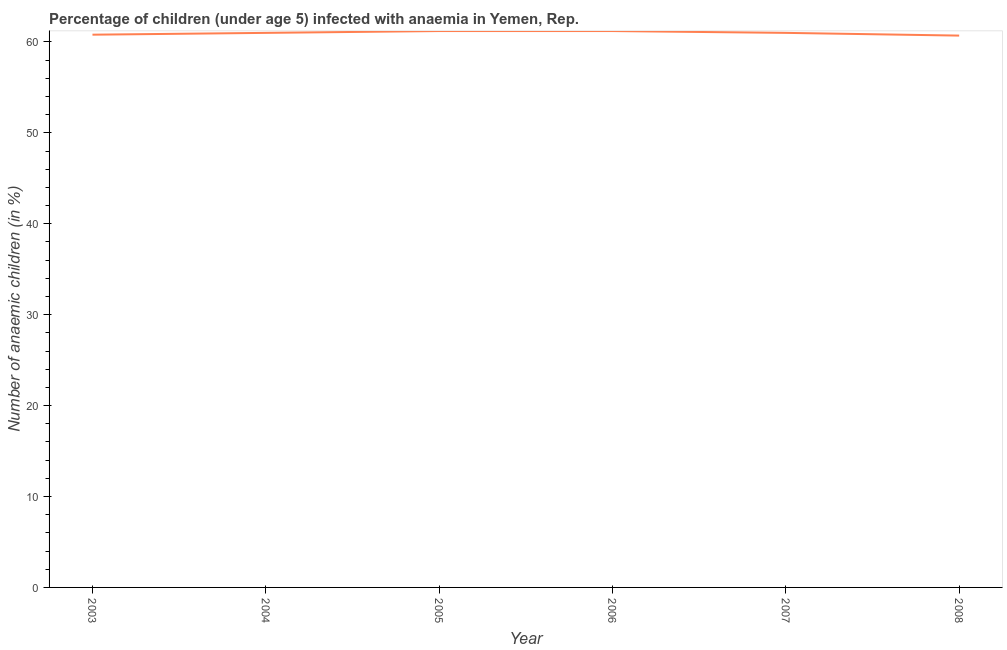Across all years, what is the maximum number of anaemic children?
Your answer should be compact. 61.2. Across all years, what is the minimum number of anaemic children?
Keep it short and to the point. 60.7. In which year was the number of anaemic children maximum?
Make the answer very short. 2005. What is the sum of the number of anaemic children?
Provide a short and direct response. 365.9. What is the difference between the number of anaemic children in 2003 and 2008?
Your answer should be compact. 0.1. What is the average number of anaemic children per year?
Your answer should be compact. 60.98. What is the median number of anaemic children?
Provide a succinct answer. 61. What is the ratio of the number of anaemic children in 2004 to that in 2008?
Your response must be concise. 1. What is the difference between the highest and the lowest number of anaemic children?
Provide a succinct answer. 0.5. How many lines are there?
Offer a terse response. 1. What is the difference between two consecutive major ticks on the Y-axis?
Make the answer very short. 10. What is the title of the graph?
Your answer should be very brief. Percentage of children (under age 5) infected with anaemia in Yemen, Rep. What is the label or title of the Y-axis?
Provide a succinct answer. Number of anaemic children (in %). What is the Number of anaemic children (in %) in 2003?
Offer a very short reply. 60.8. What is the Number of anaemic children (in %) in 2005?
Your answer should be very brief. 61.2. What is the Number of anaemic children (in %) of 2006?
Make the answer very short. 61.2. What is the Number of anaemic children (in %) of 2008?
Offer a very short reply. 60.7. What is the difference between the Number of anaemic children (in %) in 2003 and 2004?
Your answer should be compact. -0.2. What is the difference between the Number of anaemic children (in %) in 2003 and 2005?
Your answer should be very brief. -0.4. What is the difference between the Number of anaemic children (in %) in 2003 and 2007?
Provide a succinct answer. -0.2. What is the difference between the Number of anaemic children (in %) in 2003 and 2008?
Your answer should be very brief. 0.1. What is the difference between the Number of anaemic children (in %) in 2004 and 2005?
Ensure brevity in your answer.  -0.2. What is the difference between the Number of anaemic children (in %) in 2004 and 2007?
Offer a terse response. 0. What is the difference between the Number of anaemic children (in %) in 2005 and 2006?
Your answer should be very brief. 0. What is the difference between the Number of anaemic children (in %) in 2006 and 2007?
Give a very brief answer. 0.2. What is the difference between the Number of anaemic children (in %) in 2007 and 2008?
Offer a very short reply. 0.3. What is the ratio of the Number of anaemic children (in %) in 2003 to that in 2004?
Ensure brevity in your answer.  1. What is the ratio of the Number of anaemic children (in %) in 2003 to that in 2008?
Ensure brevity in your answer.  1. What is the ratio of the Number of anaemic children (in %) in 2004 to that in 2008?
Offer a very short reply. 1. What is the ratio of the Number of anaemic children (in %) in 2005 to that in 2006?
Offer a very short reply. 1. What is the ratio of the Number of anaemic children (in %) in 2005 to that in 2007?
Your answer should be compact. 1. 